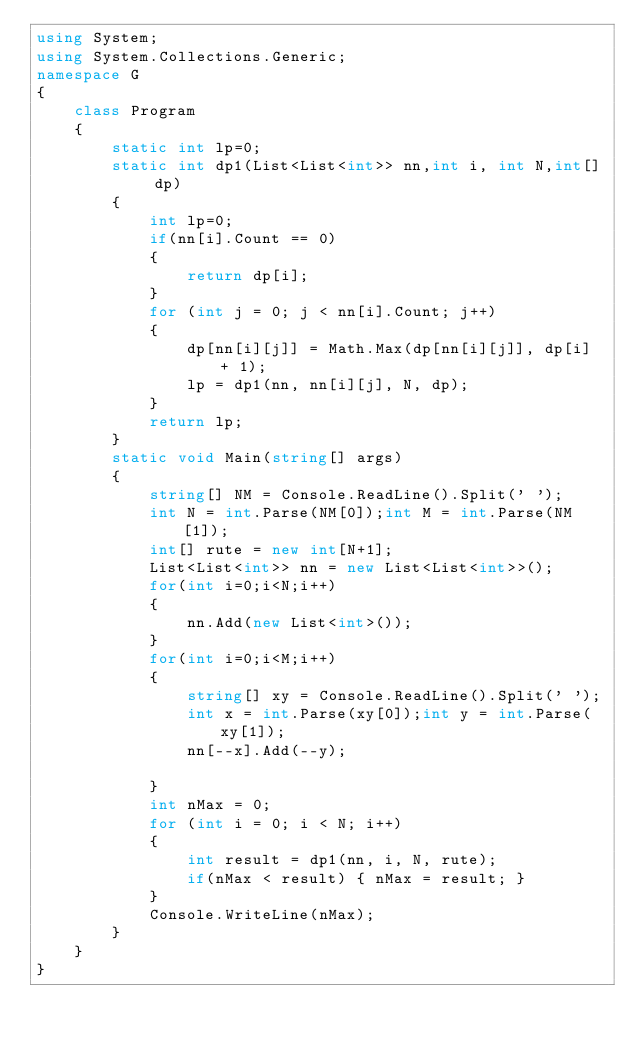<code> <loc_0><loc_0><loc_500><loc_500><_C#_>using System;
using System.Collections.Generic;
namespace G
{
    class Program
    {
        static int lp=0;
        static int dp1(List<List<int>> nn,int i, int N,int[] dp)
        {
            int lp=0;
            if(nn[i].Count == 0)
            {
                return dp[i];
            }
            for (int j = 0; j < nn[i].Count; j++)
            {
                dp[nn[i][j]] = Math.Max(dp[nn[i][j]], dp[i] + 1);
                lp = dp1(nn, nn[i][j], N, dp);
            }
            return lp;
        }
        static void Main(string[] args)
        {
            string[] NM = Console.ReadLine().Split(' ');
            int N = int.Parse(NM[0]);int M = int.Parse(NM[1]);
            int[] rute = new int[N+1];
            List<List<int>> nn = new List<List<int>>();
            for(int i=0;i<N;i++)
            {
                nn.Add(new List<int>());
            }
            for(int i=0;i<M;i++)
            {
                string[] xy = Console.ReadLine().Split(' ');
                int x = int.Parse(xy[0]);int y = int.Parse(xy[1]);
                nn[--x].Add(--y);
                
            }
            int nMax = 0;
            for (int i = 0; i < N; i++)
            {
                int result = dp1(nn, i, N, rute);
                if(nMax < result) { nMax = result; }
            }
            Console.WriteLine(nMax);
        }
    }
}
</code> 